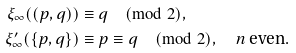Convert formula to latex. <formula><loc_0><loc_0><loc_500><loc_500>\xi _ { \infty } ( ( p , q ) ) & \equiv q \pmod { 2 } , \\ \xi ^ { \prime } _ { \infty } ( \{ p , q \} ) & \equiv p \equiv q \pmod { 2 } , \quad \text {$n$ even} .</formula> 